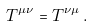<formula> <loc_0><loc_0><loc_500><loc_500>T ^ { \mu \nu } = T ^ { \nu \mu } \, .</formula> 